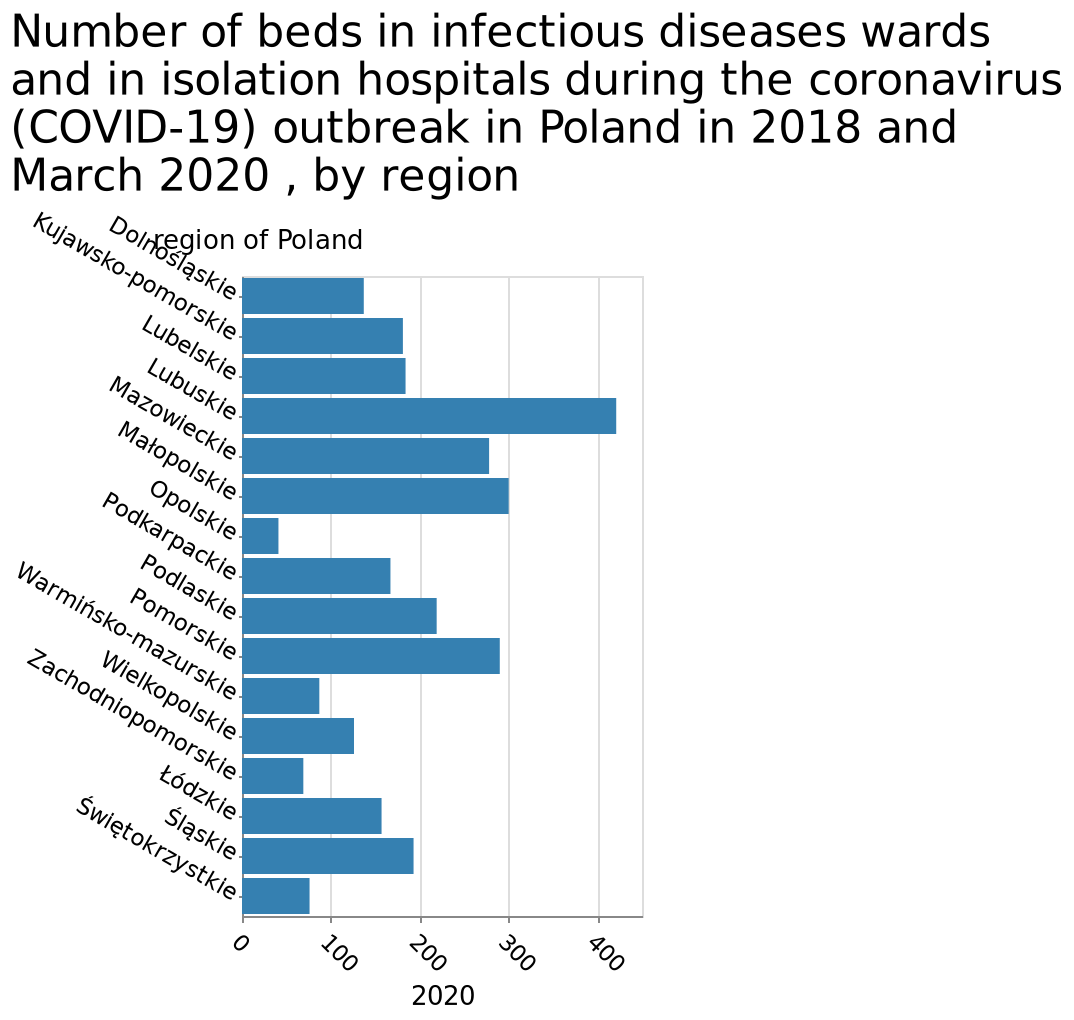<image>
Is there any data available from 2018 in the graph?  No, no data is placed from 2018 in the graph. Describe the following image in detail This bar graph is titled Number of beds in infectious diseases wards and in isolation hospitals during the coronavirus (COVID-19) outbreak in Poland in 2018 and March 2020 , by region. The x-axis plots 2020 as linear scale with a minimum of 0 and a maximum of 400 while the y-axis measures region of Poland on categorical scale starting with Dolnośląskie and ending with Świętokrzystkie. Offer a thorough analysis of the image. There are no trends visible from this graph as only the numbers from 2020 are logged, no data is placed from 2018. Are there trends visible from this graph as all the numbers from 2020 are logged, and data is placed from 2018? No.There are no trends visible from this graph as only the numbers from 2020 are logged, no data is placed from 2018. 